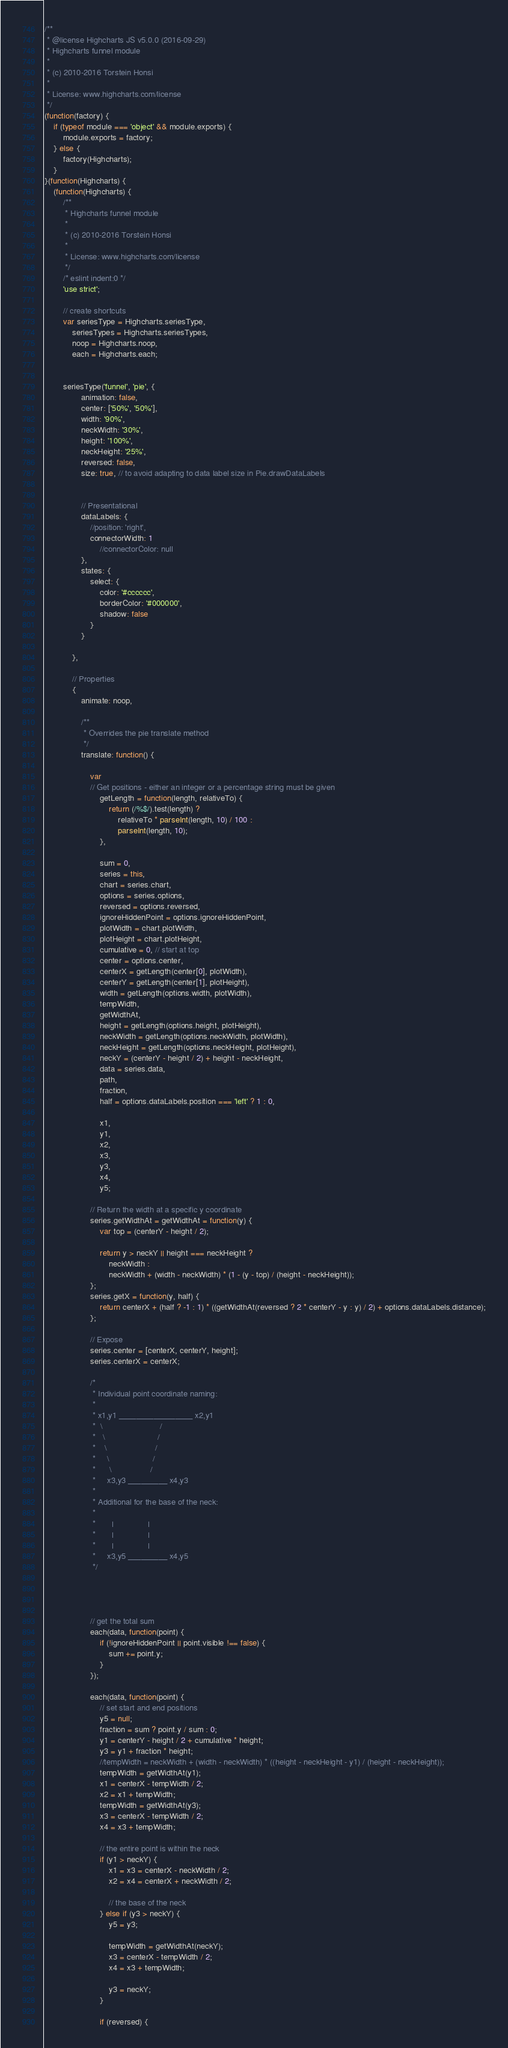<code> <loc_0><loc_0><loc_500><loc_500><_JavaScript_>/**
 * @license Highcharts JS v5.0.0 (2016-09-29)
 * Highcharts funnel module
 *
 * (c) 2010-2016 Torstein Honsi
 *
 * License: www.highcharts.com/license
 */
(function(factory) {
    if (typeof module === 'object' && module.exports) {
        module.exports = factory;
    } else {
        factory(Highcharts);
    }
}(function(Highcharts) {
    (function(Highcharts) {
        /**
         * Highcharts funnel module
         *
         * (c) 2010-2016 Torstein Honsi
         *
         * License: www.highcharts.com/license
         */
        /* eslint indent:0 */
        'use strict';

        // create shortcuts
        var seriesType = Highcharts.seriesType,
            seriesTypes = Highcharts.seriesTypes,
            noop = Highcharts.noop,
            each = Highcharts.each;


        seriesType('funnel', 'pie', {
                animation: false,
                center: ['50%', '50%'],
                width: '90%',
                neckWidth: '30%',
                height: '100%',
                neckHeight: '25%',
                reversed: false,
                size: true, // to avoid adapting to data label size in Pie.drawDataLabels


                // Presentational
                dataLabels: {
                    //position: 'right',
                    connectorWidth: 1
                        //connectorColor: null
                },
                states: {
                    select: {
                        color: '#cccccc',
                        borderColor: '#000000',
                        shadow: false
                    }
                }

            },

            // Properties
            {
                animate: noop,

                /**
                 * Overrides the pie translate method
                 */
                translate: function() {

                    var
                    // Get positions - either an integer or a percentage string must be given
                        getLength = function(length, relativeTo) {
                            return (/%$/).test(length) ?
                                relativeTo * parseInt(length, 10) / 100 :
                                parseInt(length, 10);
                        },

                        sum = 0,
                        series = this,
                        chart = series.chart,
                        options = series.options,
                        reversed = options.reversed,
                        ignoreHiddenPoint = options.ignoreHiddenPoint,
                        plotWidth = chart.plotWidth,
                        plotHeight = chart.plotHeight,
                        cumulative = 0, // start at top
                        center = options.center,
                        centerX = getLength(center[0], plotWidth),
                        centerY = getLength(center[1], plotHeight),
                        width = getLength(options.width, plotWidth),
                        tempWidth,
                        getWidthAt,
                        height = getLength(options.height, plotHeight),
                        neckWidth = getLength(options.neckWidth, plotWidth),
                        neckHeight = getLength(options.neckHeight, plotHeight),
                        neckY = (centerY - height / 2) + height - neckHeight,
                        data = series.data,
                        path,
                        fraction,
                        half = options.dataLabels.position === 'left' ? 1 : 0,

                        x1,
                        y1,
                        x2,
                        x3,
                        y3,
                        x4,
                        y5;

                    // Return the width at a specific y coordinate
                    series.getWidthAt = getWidthAt = function(y) {
                        var top = (centerY - height / 2);

                        return y > neckY || height === neckHeight ?
                            neckWidth :
                            neckWidth + (width - neckWidth) * (1 - (y - top) / (height - neckHeight));
                    };
                    series.getX = function(y, half) {
                        return centerX + (half ? -1 : 1) * ((getWidthAt(reversed ? 2 * centerY - y : y) / 2) + options.dataLabels.distance);
                    };

                    // Expose
                    series.center = [centerX, centerY, height];
                    series.centerX = centerX;

                    /*
                     * Individual point coordinate naming:
                     *
                     * x1,y1 _________________ x2,y1
                     *  \                         /
                     *   \                       /
                     *    \                     /
                     *     \                   /
                     *      \                 /
                     *     x3,y3 _________ x4,y3
                     *
                     * Additional for the base of the neck:
                     *
                     *       |               |
                     *       |               |
                     *       |               |
                     *     x3,y5 _________ x4,y5
                     */




                    // get the total sum
                    each(data, function(point) {
                        if (!ignoreHiddenPoint || point.visible !== false) {
                            sum += point.y;
                        }
                    });

                    each(data, function(point) {
                        // set start and end positions
                        y5 = null;
                        fraction = sum ? point.y / sum : 0;
                        y1 = centerY - height / 2 + cumulative * height;
                        y3 = y1 + fraction * height;
                        //tempWidth = neckWidth + (width - neckWidth) * ((height - neckHeight - y1) / (height - neckHeight));
                        tempWidth = getWidthAt(y1);
                        x1 = centerX - tempWidth / 2;
                        x2 = x1 + tempWidth;
                        tempWidth = getWidthAt(y3);
                        x3 = centerX - tempWidth / 2;
                        x4 = x3 + tempWidth;

                        // the entire point is within the neck
                        if (y1 > neckY) {
                            x1 = x3 = centerX - neckWidth / 2;
                            x2 = x4 = centerX + neckWidth / 2;

                            // the base of the neck
                        } else if (y3 > neckY) {
                            y5 = y3;

                            tempWidth = getWidthAt(neckY);
                            x3 = centerX - tempWidth / 2;
                            x4 = x3 + tempWidth;

                            y3 = neckY;
                        }

                        if (reversed) {</code> 